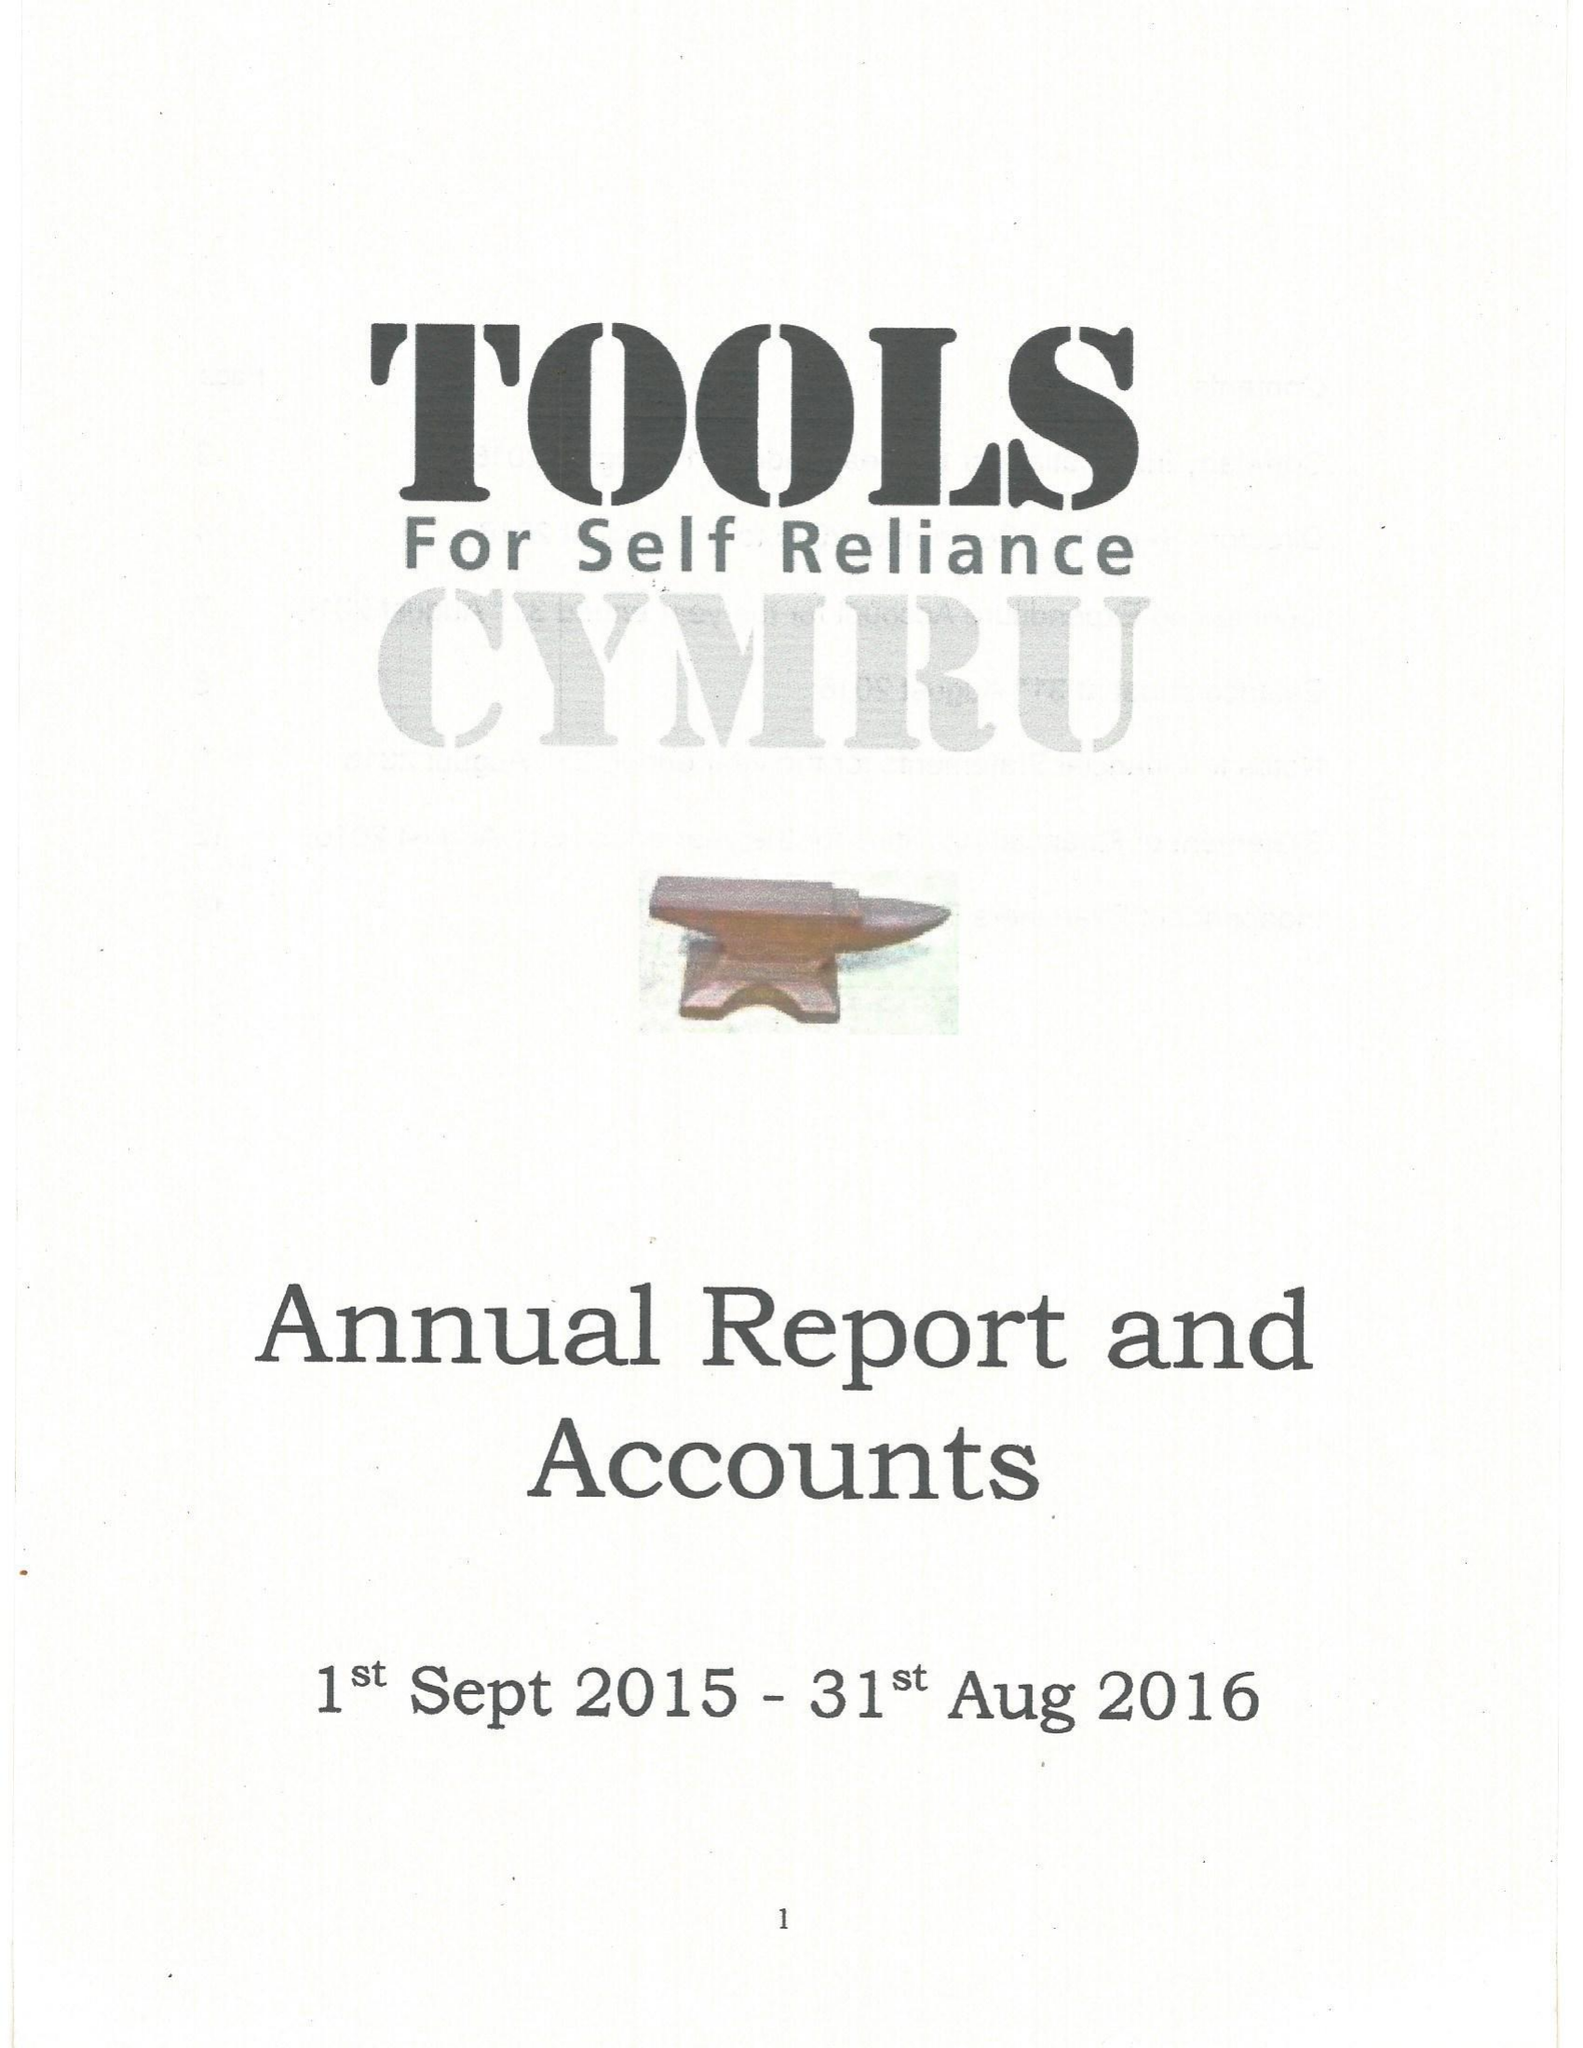What is the value for the address__postcode?
Answer the question using a single word or phrase. NP8 1BZ 